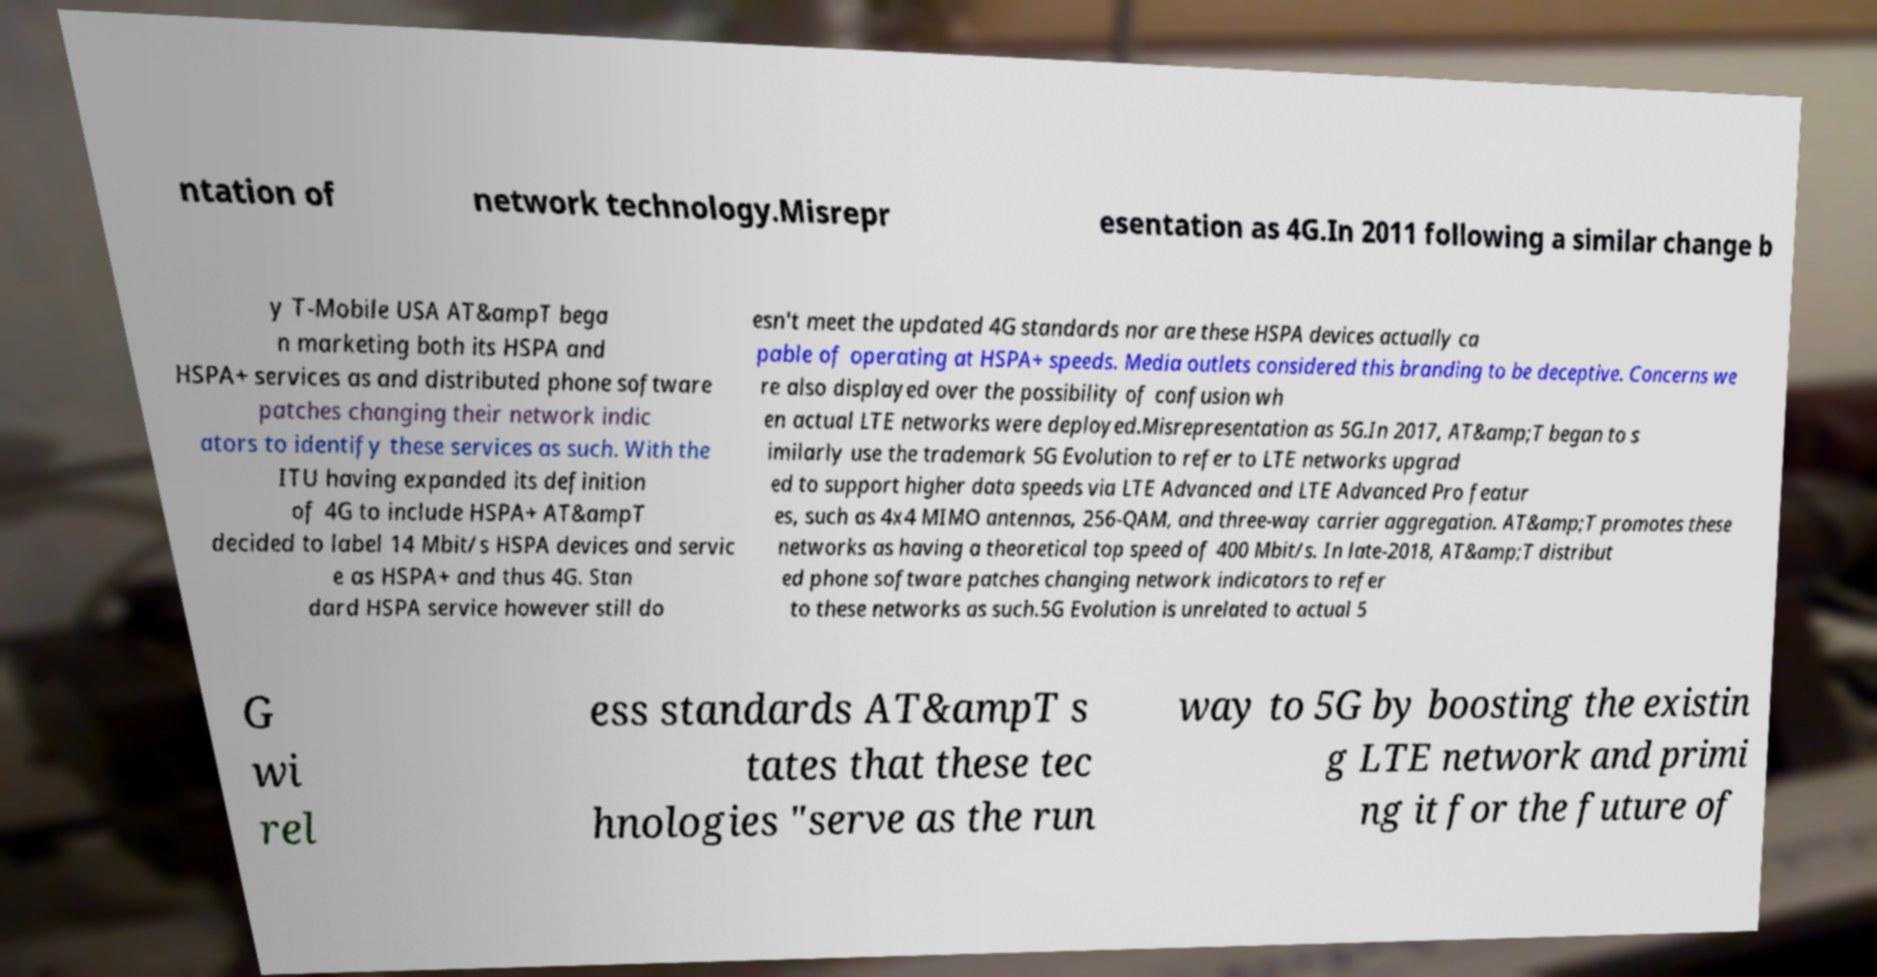Please identify and transcribe the text found in this image. ntation of network technology.Misrepr esentation as 4G.In 2011 following a similar change b y T-Mobile USA AT&ampT bega n marketing both its HSPA and HSPA+ services as and distributed phone software patches changing their network indic ators to identify these services as such. With the ITU having expanded its definition of 4G to include HSPA+ AT&ampT decided to label 14 Mbit/s HSPA devices and servic e as HSPA+ and thus 4G. Stan dard HSPA service however still do esn't meet the updated 4G standards nor are these HSPA devices actually ca pable of operating at HSPA+ speeds. Media outlets considered this branding to be deceptive. Concerns we re also displayed over the possibility of confusion wh en actual LTE networks were deployed.Misrepresentation as 5G.In 2017, AT&amp;T began to s imilarly use the trademark 5G Evolution to refer to LTE networks upgrad ed to support higher data speeds via LTE Advanced and LTE Advanced Pro featur es, such as 4x4 MIMO antennas, 256-QAM, and three-way carrier aggregation. AT&amp;T promotes these networks as having a theoretical top speed of 400 Mbit/s. In late-2018, AT&amp;T distribut ed phone software patches changing network indicators to refer to these networks as such.5G Evolution is unrelated to actual 5 G wi rel ess standards AT&ampT s tates that these tec hnologies "serve as the run way to 5G by boosting the existin g LTE network and primi ng it for the future of 